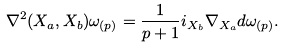Convert formula to latex. <formula><loc_0><loc_0><loc_500><loc_500>\nabla ^ { 2 } ( X _ { a } , X _ { b } ) \omega _ { ( p ) } = \frac { 1 } { p + 1 } i _ { X _ { b } } \nabla _ { X _ { a } } d \omega _ { ( p ) } .</formula> 